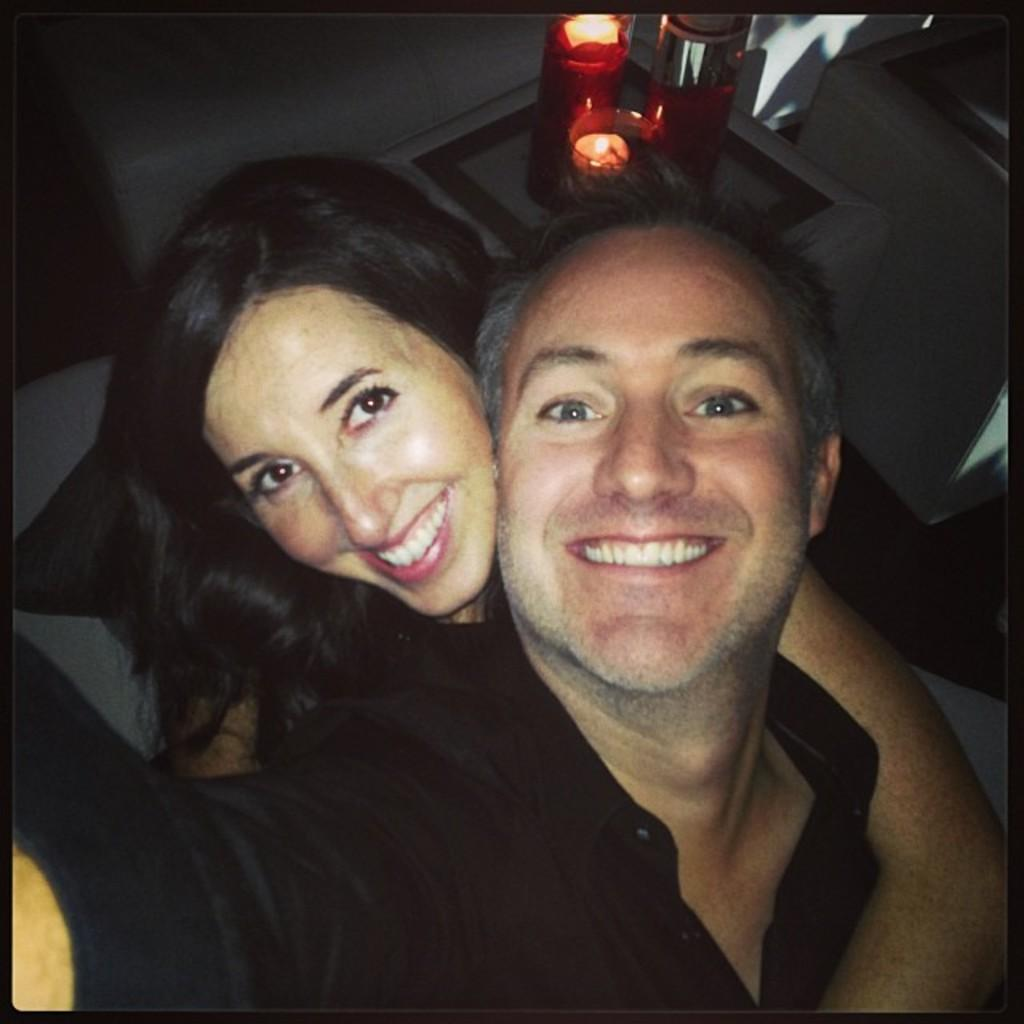Who is present in the image? There is a man and a woman in the image. What are the facial expressions of the people in the image? Both the man and the woman are smiling in the image. What objects can be seen in the image besides the people? There are two candles in the image. What is the color of the surface on which the candles are placed? The candles are placed on a white surface. What type of badge is the man wearing in the image? There is no badge visible on the man in the image. How many spiders are crawling on the woman's shoulder in the image? There are no spiders present in the image. 